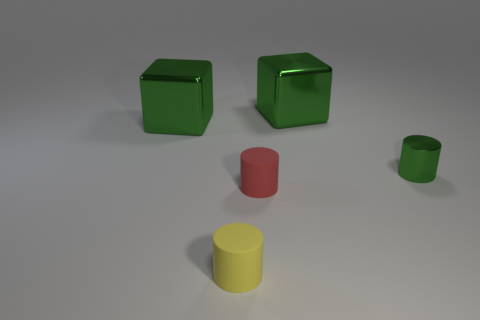Are there fewer green metallic cubes than small metal cylinders?
Keep it short and to the point. No. How many other objects are there of the same color as the tiny metal cylinder?
Provide a succinct answer. 2. How many shiny blocks are there?
Give a very brief answer. 2. Is the number of big green metal blocks that are in front of the tiny green shiny object less than the number of big cyan rubber objects?
Ensure brevity in your answer.  No. Does the object in front of the tiny red rubber cylinder have the same material as the tiny red cylinder?
Your answer should be compact. Yes. The large green object left of the green block to the right of the green metal object that is to the left of the yellow matte cylinder is what shape?
Provide a short and direct response. Cube. Is there a red rubber thing of the same size as the yellow rubber cylinder?
Keep it short and to the point. Yes. What number of cyan matte cylinders are the same size as the yellow rubber object?
Keep it short and to the point. 0. Is the number of green metallic cubes on the left side of the tiny yellow matte thing less than the number of green metal things to the left of the small shiny cylinder?
Ensure brevity in your answer.  Yes. How big is the green metallic thing that is behind the big cube that is in front of the green block that is right of the tiny yellow matte object?
Make the answer very short. Large. 